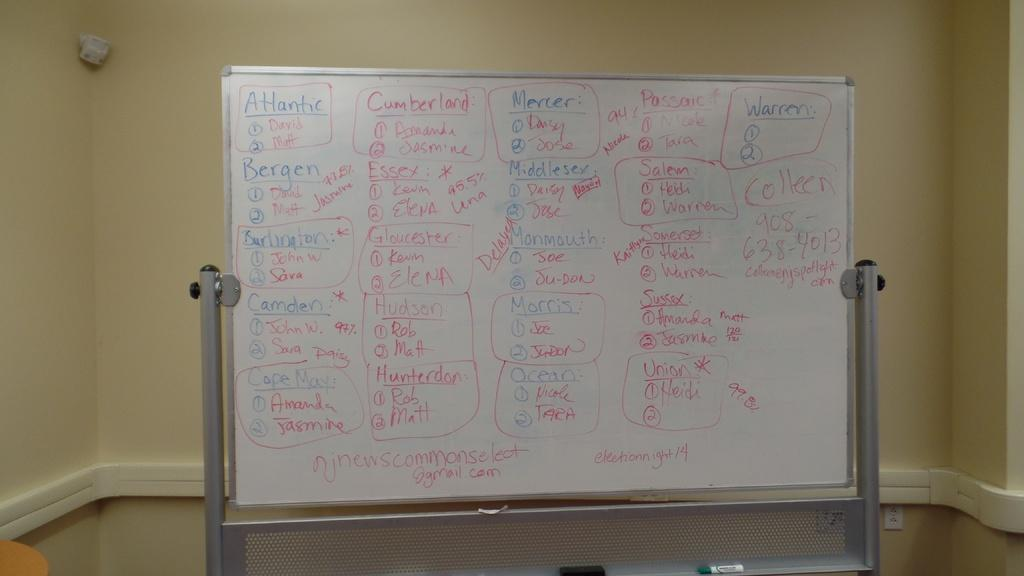Provide a one-sentence caption for the provided image. A white board with writing all over it divided into categories including Atlantic and Cumberland. 